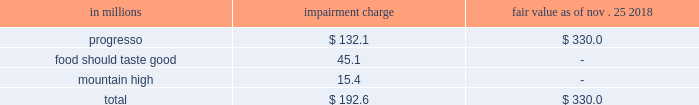Valuation of long-lived assets we estimate the useful lives of long-lived assets and make estimates concerning undiscounted cash flows to review for impairment whenever events or changes in circumstances indicate that the carrying amount of an asset ( or asset group ) may not be recoverable .
Fair value is measured using discounted cash flows or independent appraisals , as appropriate .
Intangible assets goodwill and other indefinite-lived intangible assets are not subject to amortization and are tested for impairment annually and whenever events or changes in circumstances indicate that impairment may have occurred .
Our estimates of fair value for goodwill impairment testing are determined based on a discounted cash flow model .
We use inputs from our long-range planning process to determine growth rates for sales and profits .
We also make estimates of discount rates , perpetuity growth assumptions , market comparables , and other factors .
We evaluate the useful lives of our other intangible assets , mainly brands , to determine if they are finite or indefinite-lived .
Reaching a determination on useful life requires significant judgments and assumptions regarding the future effects of obsolescence , demand , competition , other economic factors ( such as the stability of the industry , known technological advances , legislative action that results in an uncertain or changing regulatory environment , and expected changes in distribution channels ) , the level of required maintenance expenditures , and the expected lives of other related groups of assets .
Intangible assets that are deemed to have definite lives are amortized on a straight-line basis , over their useful lives , generally ranging from 4 to 30 years .
Our estimate of the fair value of our brand assets is based on a discounted cash flow model using inputs which include projected revenues from our long-range plan , assumed royalty rates that could be payable if we did not own the brands , and a discount rate .
As of may 26 , 2019 , we had $ 20.6 billion of goodwill and indefinite-lived intangible assets .
While we currently believe that the fair value of each intangible exceeds its carrying value and that those intangibles so classified will contribute indefinitely to our cash flows , materially different assumptions regarding future performance of our businesses or a different weighted-average cost of capital could result in material impairment losses and amortization expense .
We performed our fiscal 2019 assessment of our intangible assets as of the first day of the second quarter of fiscal 2019 .
As a result of lower sales projections in our long-range plans for the businesses supporting the progresso , food should taste good , and mountain high brand intangible assets , we recorded the following impairment charges : in millions impairment charge fair value nov .
25 , 2018 progresso $ 132.1 $ 330.0 food should taste good 45.1 - mountain high 15.4 - .
Significant assumptions used in that assessment included our long-range cash flow projections for the businesses , royalty rates , weighted-average cost of capital rates , and tax rates. .
By how much is the net income reduced due to the impairment charges? 
Computations: ((132.1 + 45.1) + 15.4)
Answer: 192.6. 